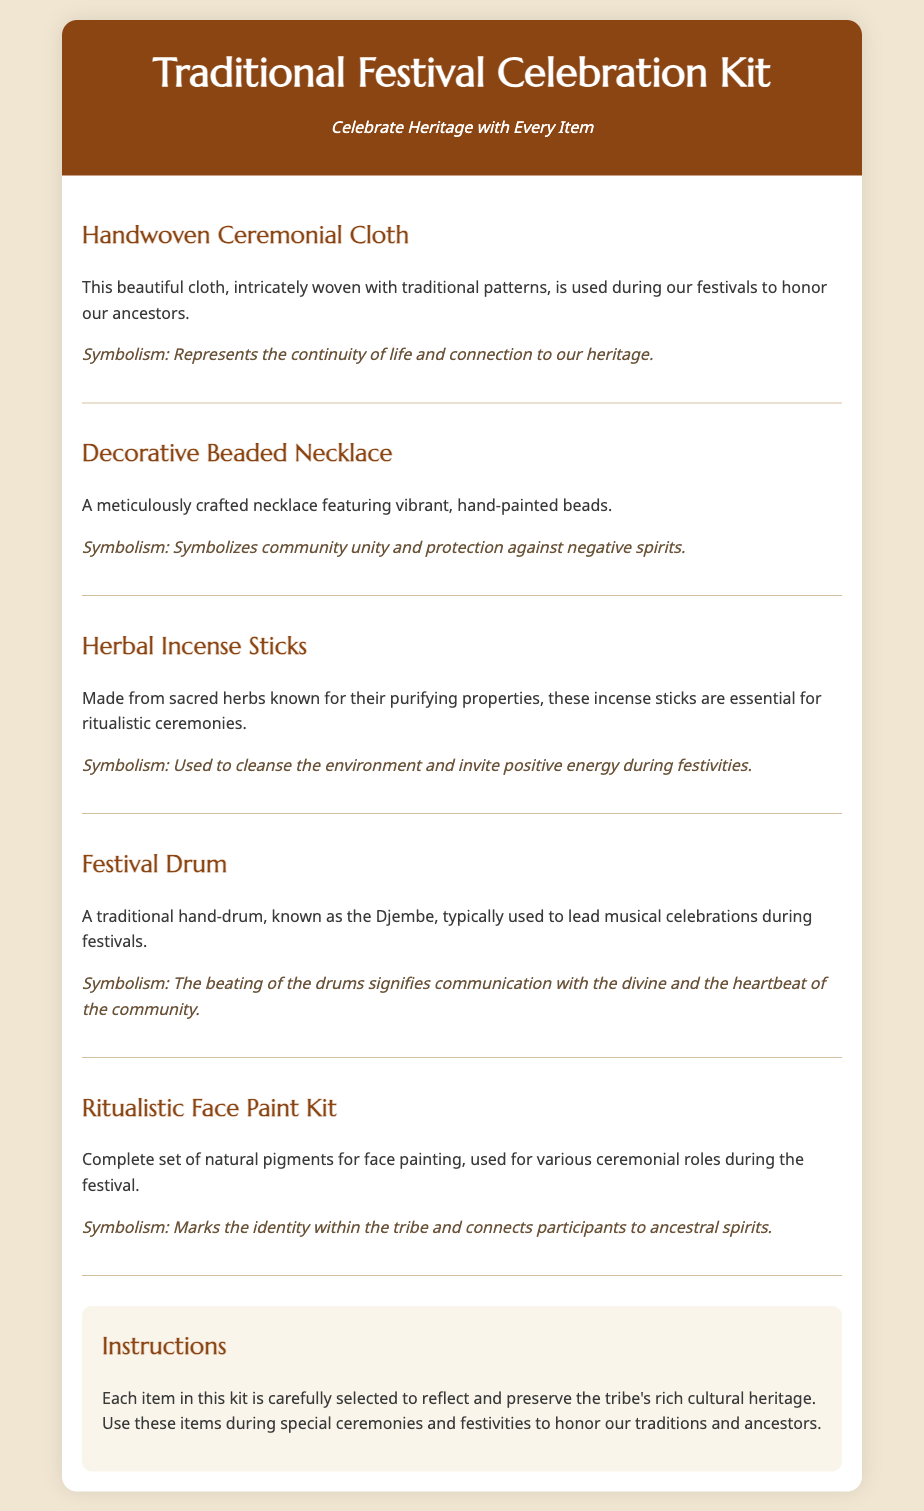what is the title of the kit? The title of the kit is presented prominently at the top of the document.
Answer: Traditional Festival Celebration Kit how many items are in the kit? The document lists five distinct items within the kit.
Answer: Five what does the Handwoven Ceremonial Cloth represent? The symbolism of the Handwoven Ceremonial Cloth is explicitly stated in its description.
Answer: Continuity of life and connection to our heritage what is the purpose of the Herbal Incense Sticks? The document specifies the use of the Herbal Incense Sticks in ritualistic ceremonies.
Answer: Purifying properties what musical instrument is included in the kit? The document provides the name of the traditional instrument included in the kit.
Answer: Djembe what does the Ritualistic Face Paint Kit connect participants to? The description of the Ritualistic Face Paint Kit reveals its connection purpose.
Answer: Ancestral spirits what type of materials are the beads made from? The item description specifies the materials used in the Decorative Beaded Necklace.
Answer: Hand-painted beads what is highlighted in the "Instructions" section? The instructions provided indicate the main focus of using the kit items.
Answer: Honor our traditions and ancestors 